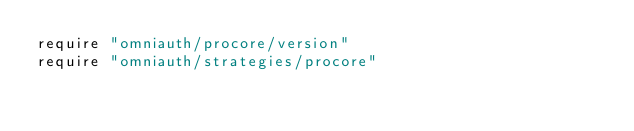Convert code to text. <code><loc_0><loc_0><loc_500><loc_500><_Ruby_>require "omniauth/procore/version"
require "omniauth/strategies/procore"
</code> 